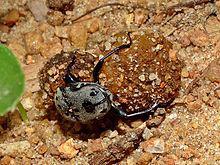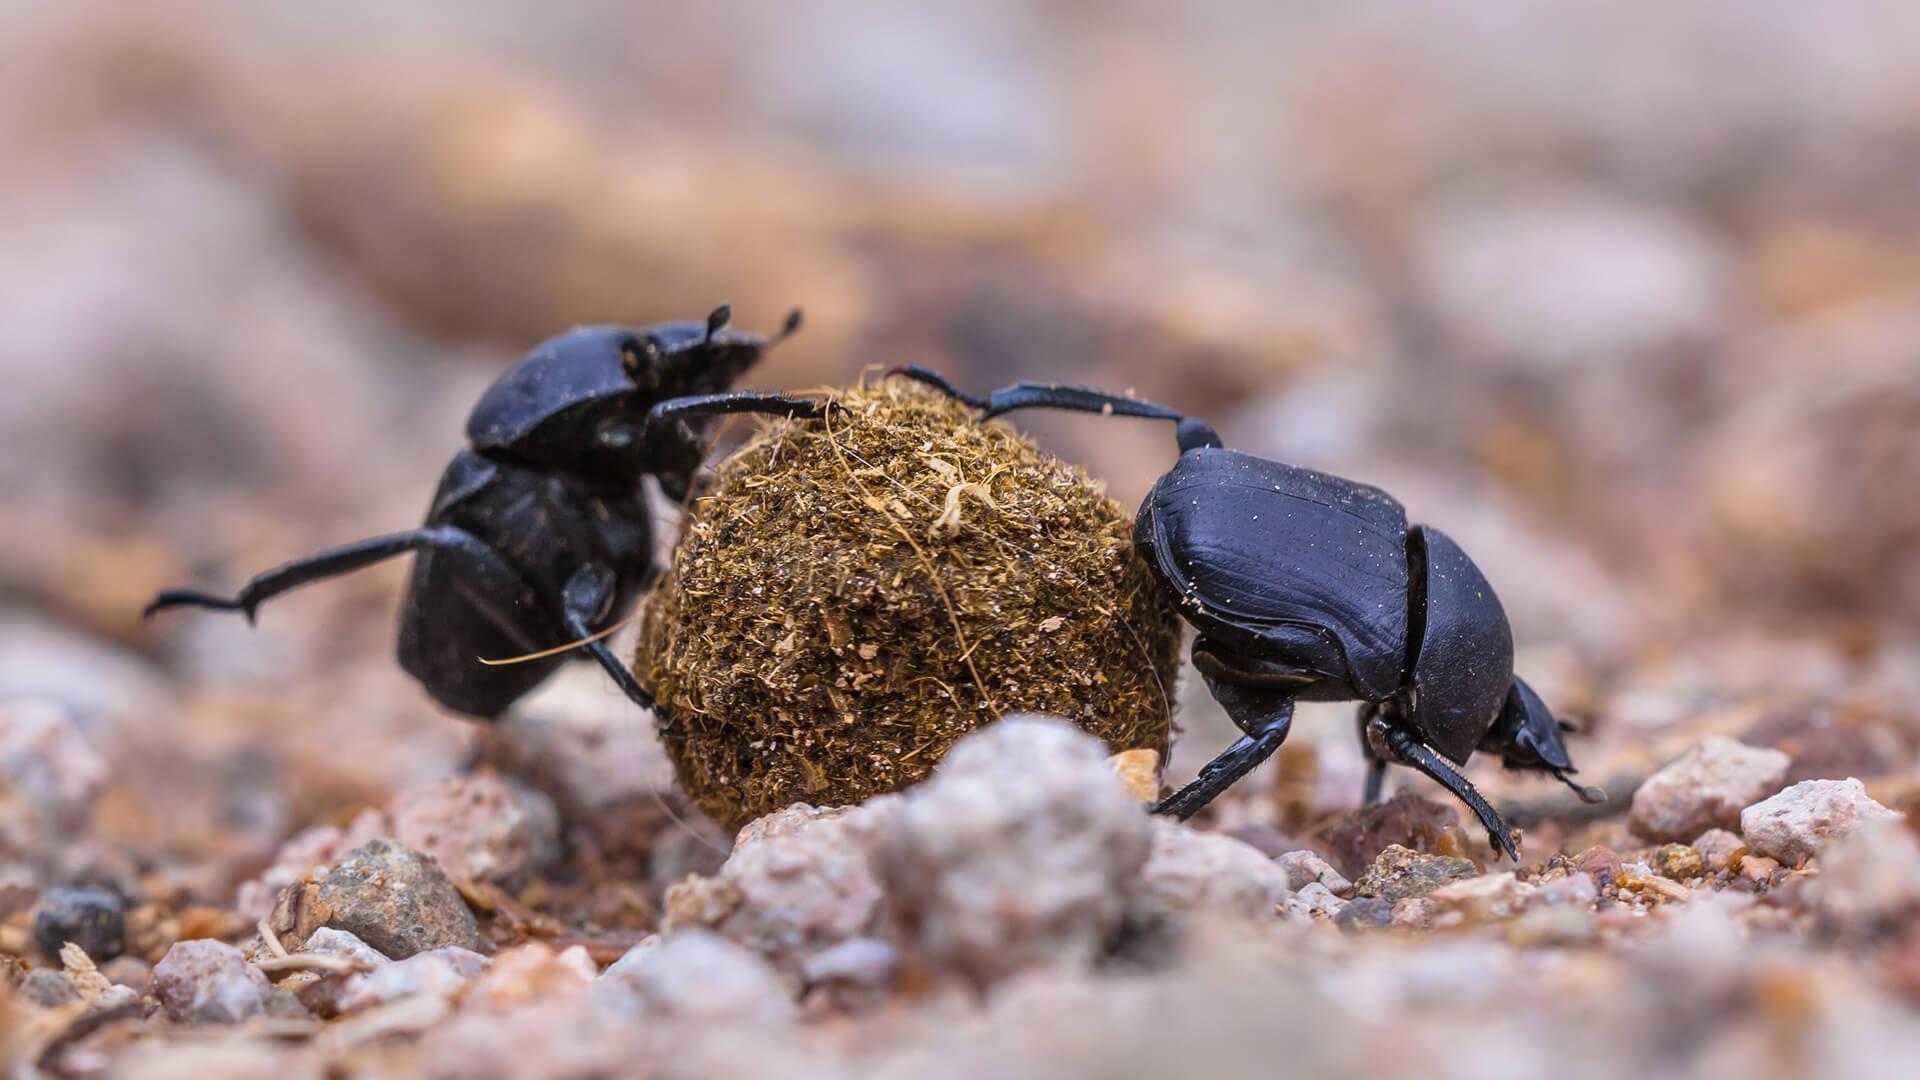The first image is the image on the left, the second image is the image on the right. Assess this claim about the two images: "There are exactly two insects in one of the images.". Correct or not? Answer yes or no. Yes. 